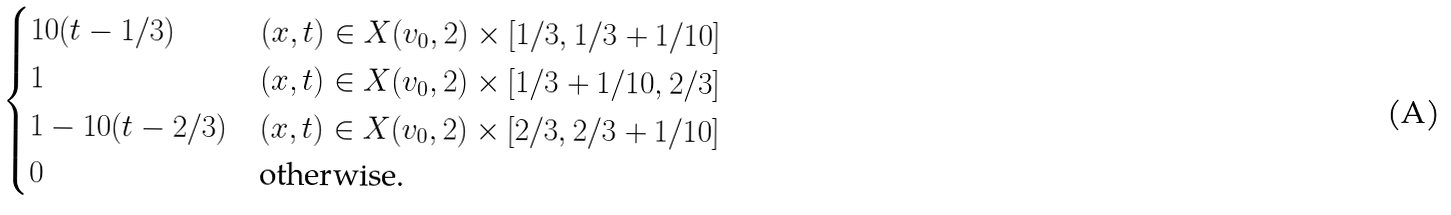Convert formula to latex. <formula><loc_0><loc_0><loc_500><loc_500>\begin{cases} 1 0 ( t - 1 / 3 ) & ( x , t ) \in X ( v _ { 0 } , 2 ) \times [ 1 / 3 , 1 / 3 + 1 / 1 0 ] \\ 1 & ( x , t ) \in X ( v _ { 0 } , 2 ) \times [ 1 / 3 + 1 / 1 0 , 2 / 3 ] \\ 1 - 1 0 ( t - 2 / 3 ) & ( x , t ) \in X ( v _ { 0 } , 2 ) \times [ 2 / 3 , 2 / 3 + 1 / 1 0 ] \\ 0 & \text {otherwise.} \end{cases}</formula> 